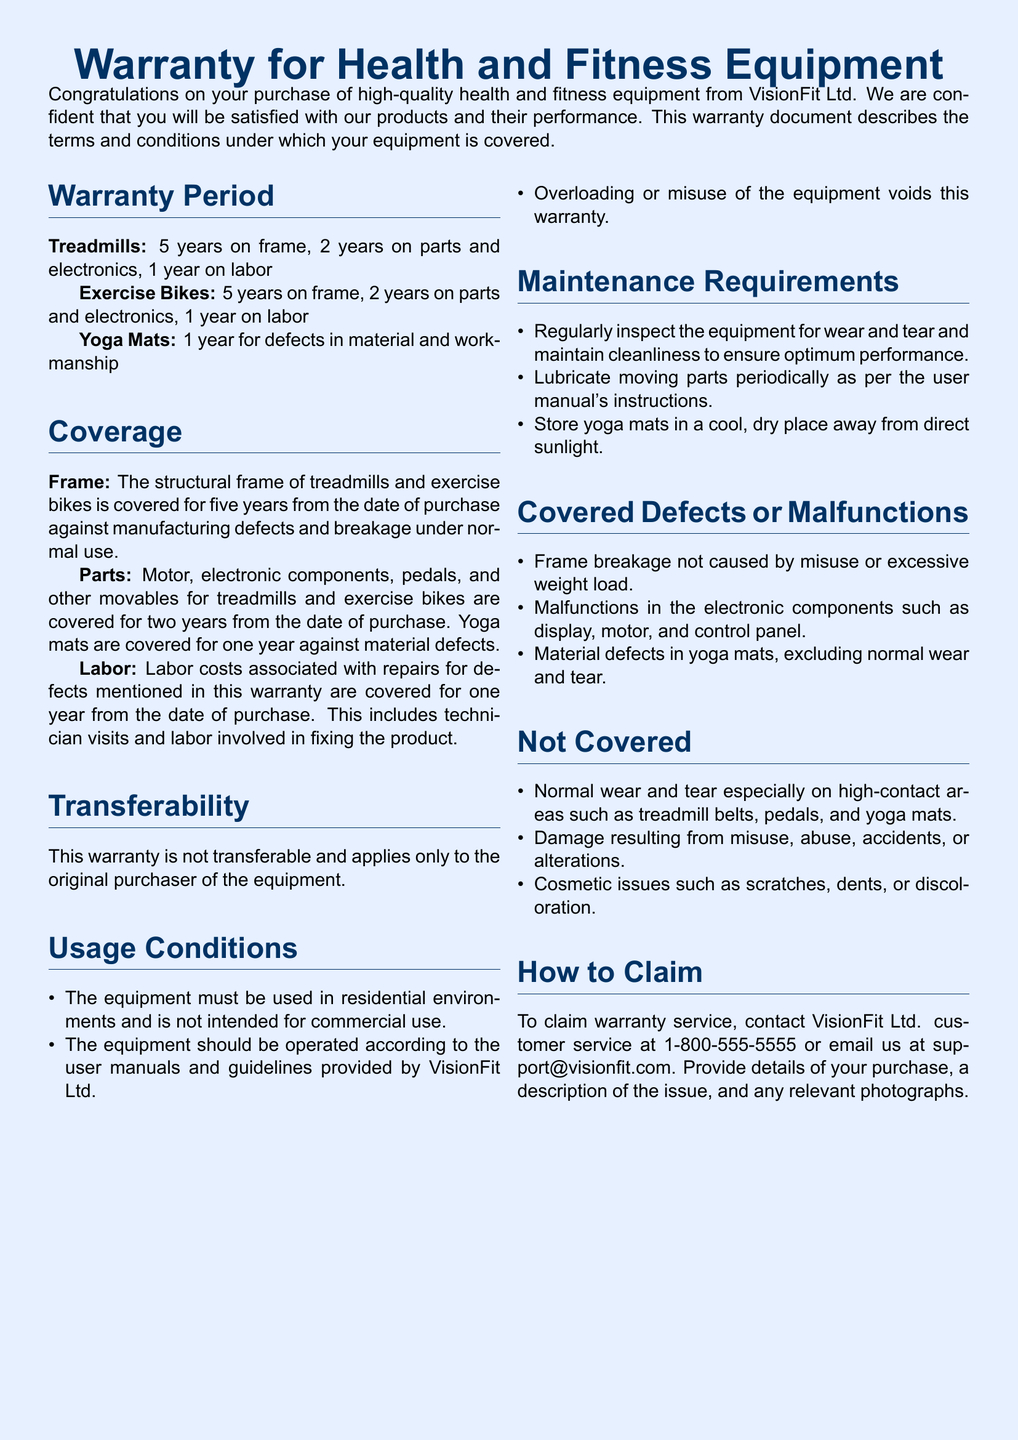What is the warranty period for treadmills? The warranty period for treadmills is specified as 5 years on frame, 2 years on parts and electronics, and 1 year on labor.
Answer: 5 years What components of exercise bikes are covered for two years? The document specifies that the motor, electronic components, pedals, and other movables are covered for two years on exercise bikes.
Answer: Motor, electronic components, pedals Is the warranty transferable? The document clearly states that this warranty is not transferable and applies only to the original purchaser of the equipment.
Answer: No What are the maintenance requirements for yoga mats? The maintenance requirements state that yoga mats should be stored in a cool, dry place away from direct sunlight.
Answer: Cool, dry place What kind of defects are covered under this warranty? The document lists frame breakage not caused by misuse, electronic component malfunctions, and material defects in yoga mats as covered defects.
Answer: Frame breakage, electronic malfunctions, material defects According to the document, what will void the warranty? The warranty will be voided by overloading or misuse of the equipment as per the document.
Answer: Overloading or misuse How can a customer claim warranty service? Warranty service can be claimed by contacting VisionFit Ltd. customer service at 1-800-555-5555 or emailing support@visionfit.com.
Answer: Contact customer service at 1-800-555-5555 What is the coverage period for labor costs associated with repairs? Labor costs associated with repairs for defects mentioned in this warranty are covered for one year from the date of purchase.
Answer: 1 year 